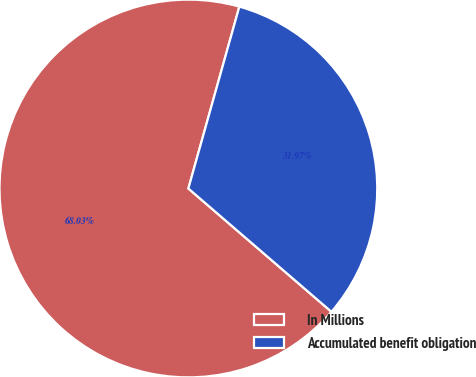Convert chart to OTSL. <chart><loc_0><loc_0><loc_500><loc_500><pie_chart><fcel>In Millions<fcel>Accumulated benefit obligation<nl><fcel>68.03%<fcel>31.97%<nl></chart> 